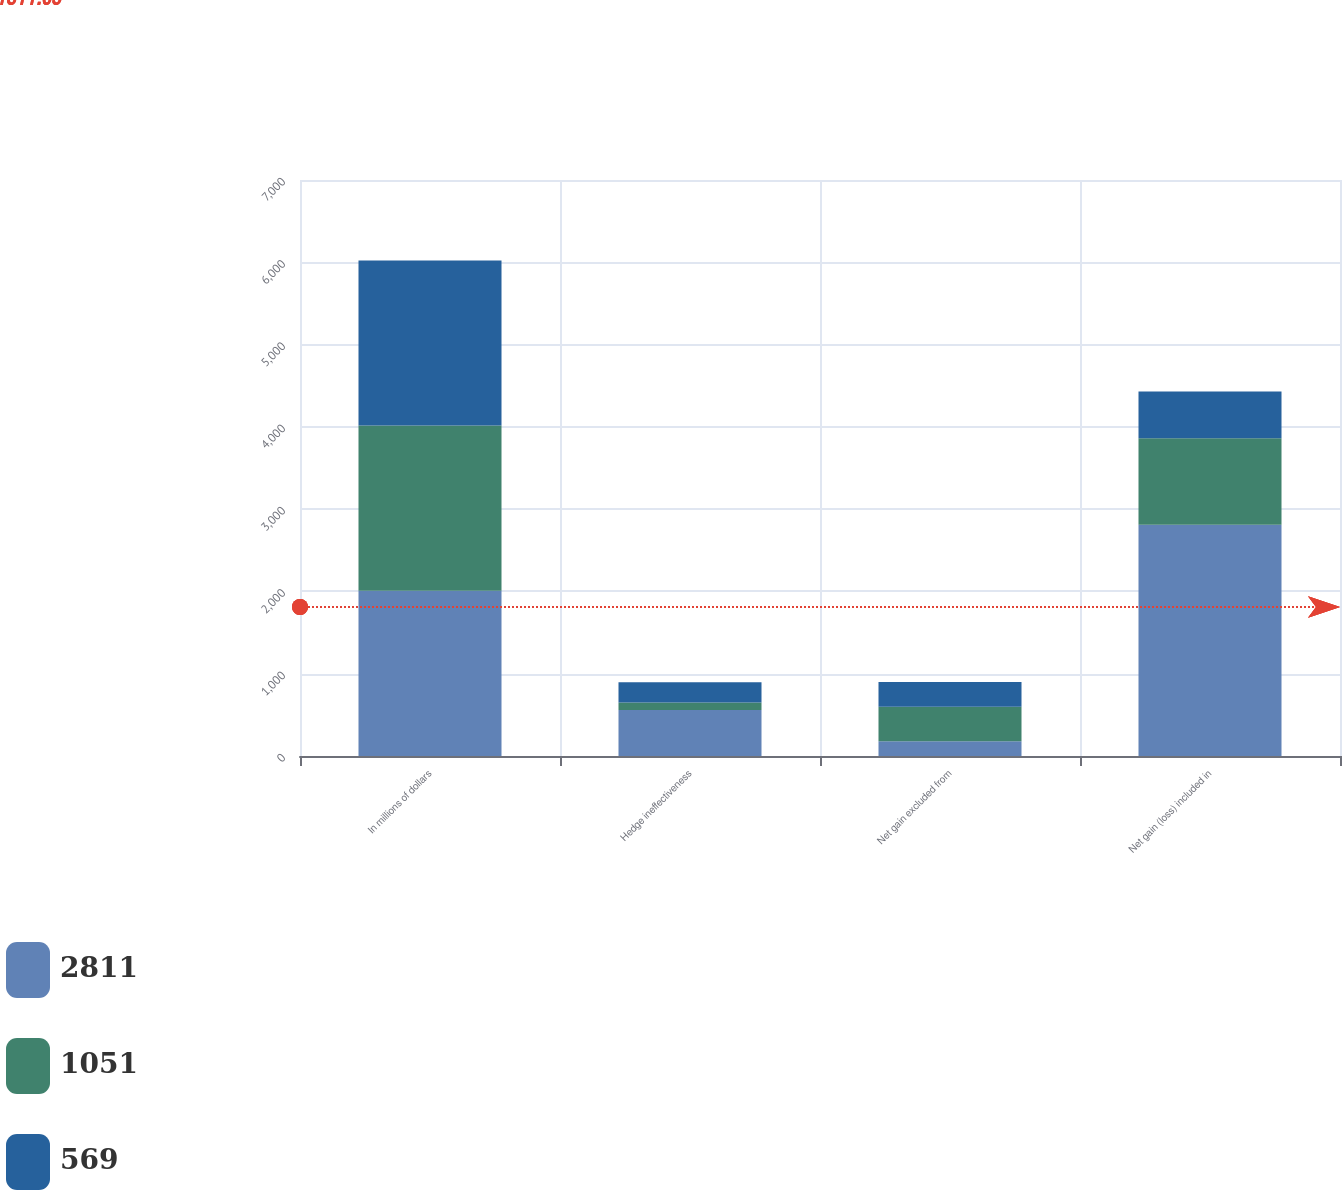<chart> <loc_0><loc_0><loc_500><loc_500><stacked_bar_chart><ecel><fcel>In millions of dollars<fcel>Hedge ineffectiveness<fcel>Net gain excluded from<fcel>Net gain (loss) included in<nl><fcel>2811<fcel>2008<fcel>559<fcel>178<fcel>2811<nl><fcel>1051<fcel>2007<fcel>91<fcel>420<fcel>1051<nl><fcel>569<fcel>2006<fcel>245<fcel>302<fcel>569<nl></chart> 